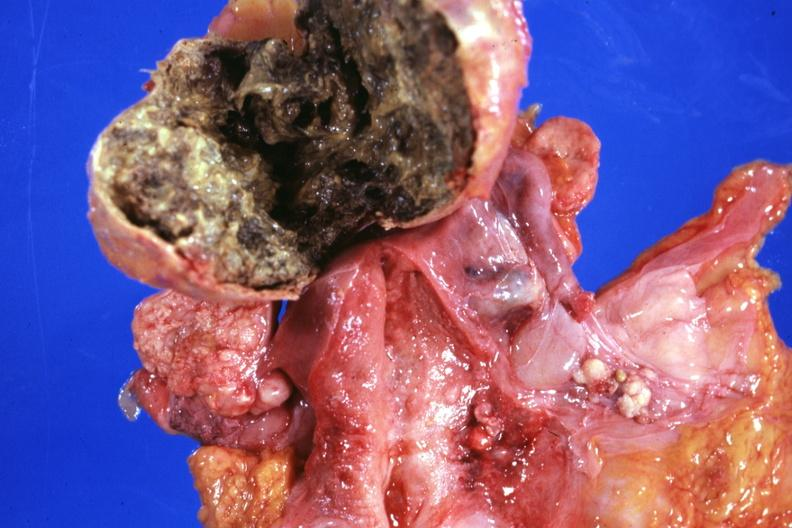s adenoma present?
Answer the question using a single word or phrase. No 